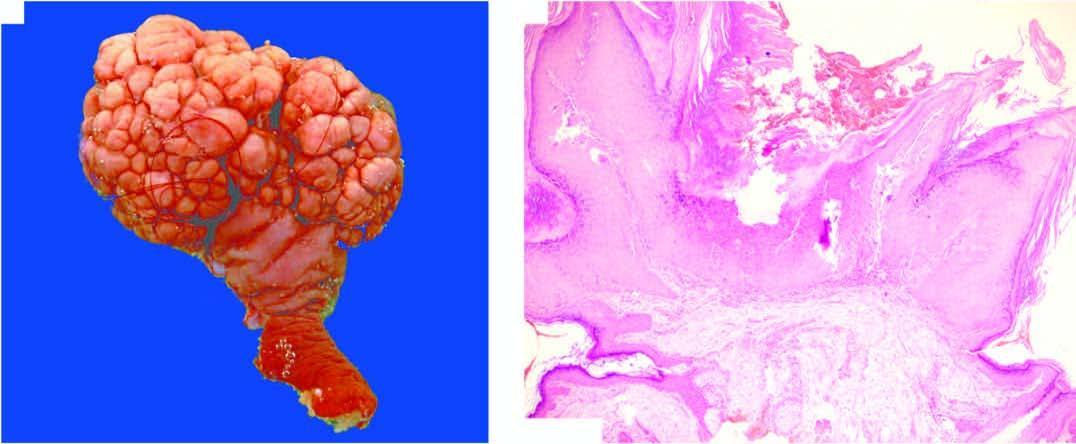does the skin surface show a papillary growth with a pedicle?
Answer the question using a single word or phrase. Yes 